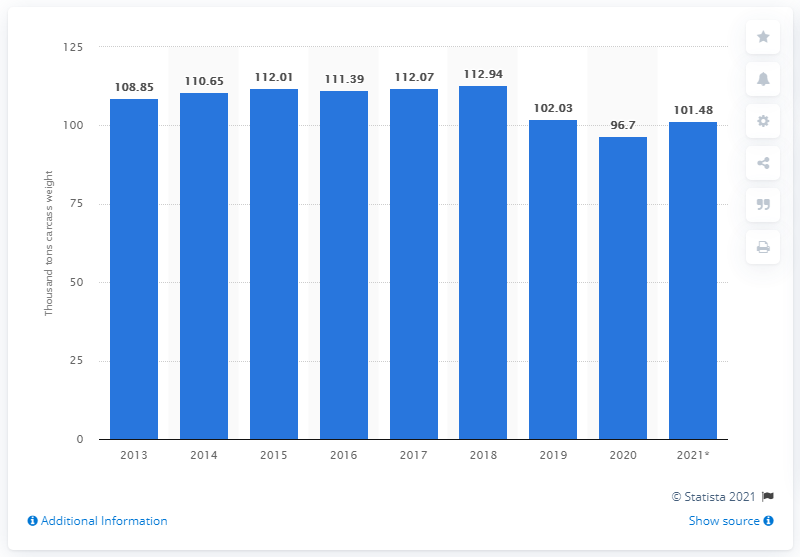Highlight a few significant elements in this photo. In 2018, the global production of pork was 112.94 million metric tons. The projected production of pork in metric tons by 2021 is 101.48 tons. 